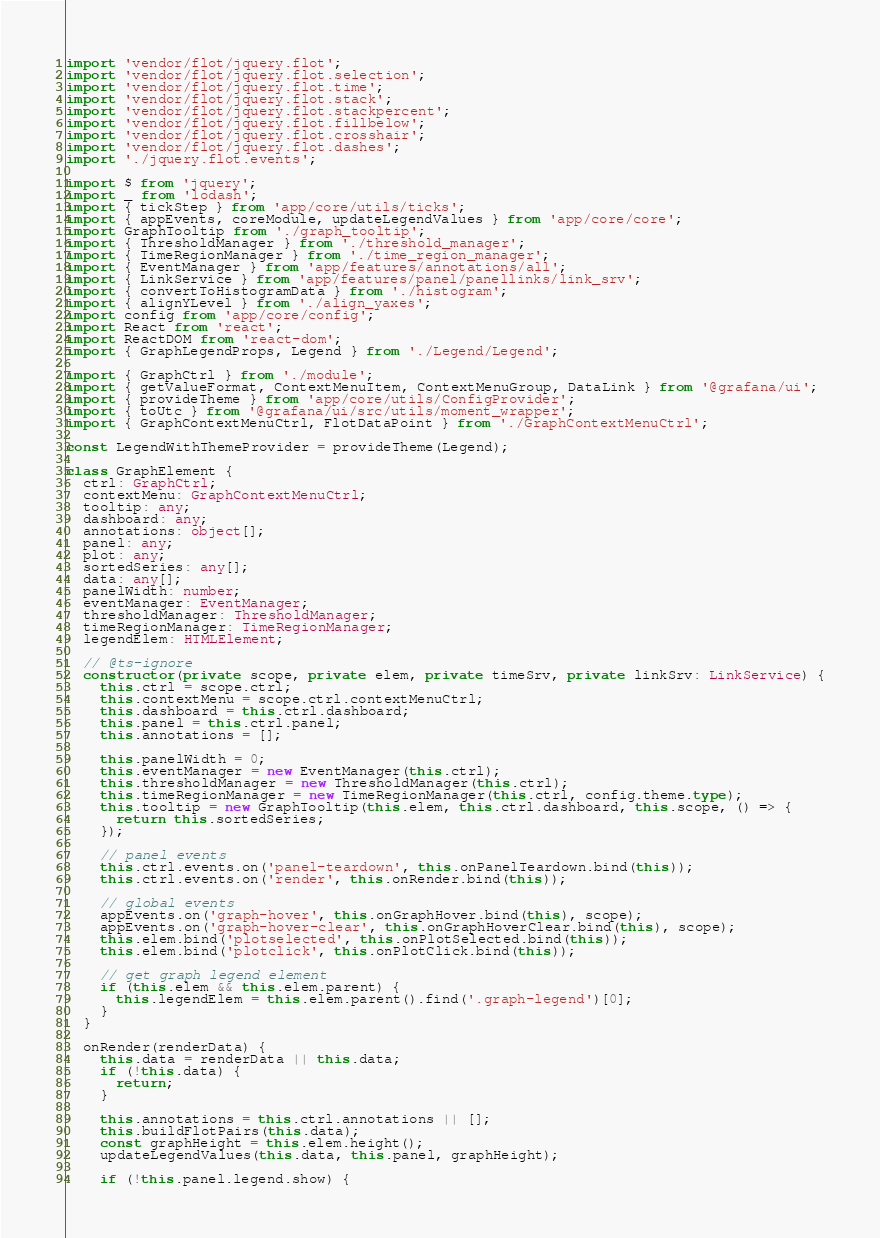Convert code to text. <code><loc_0><loc_0><loc_500><loc_500><_TypeScript_>import 'vendor/flot/jquery.flot';
import 'vendor/flot/jquery.flot.selection';
import 'vendor/flot/jquery.flot.time';
import 'vendor/flot/jquery.flot.stack';
import 'vendor/flot/jquery.flot.stackpercent';
import 'vendor/flot/jquery.flot.fillbelow';
import 'vendor/flot/jquery.flot.crosshair';
import 'vendor/flot/jquery.flot.dashes';
import './jquery.flot.events';

import $ from 'jquery';
import _ from 'lodash';
import { tickStep } from 'app/core/utils/ticks';
import { appEvents, coreModule, updateLegendValues } from 'app/core/core';
import GraphTooltip from './graph_tooltip';
import { ThresholdManager } from './threshold_manager';
import { TimeRegionManager } from './time_region_manager';
import { EventManager } from 'app/features/annotations/all';
import { LinkService } from 'app/features/panel/panellinks/link_srv';
import { convertToHistogramData } from './histogram';
import { alignYLevel } from './align_yaxes';
import config from 'app/core/config';
import React from 'react';
import ReactDOM from 'react-dom';
import { GraphLegendProps, Legend } from './Legend/Legend';

import { GraphCtrl } from './module';
import { getValueFormat, ContextMenuItem, ContextMenuGroup, DataLink } from '@grafana/ui';
import { provideTheme } from 'app/core/utils/ConfigProvider';
import { toUtc } from '@grafana/ui/src/utils/moment_wrapper';
import { GraphContextMenuCtrl, FlotDataPoint } from './GraphContextMenuCtrl';

const LegendWithThemeProvider = provideTheme(Legend);

class GraphElement {
  ctrl: GraphCtrl;
  contextMenu: GraphContextMenuCtrl;
  tooltip: any;
  dashboard: any;
  annotations: object[];
  panel: any;
  plot: any;
  sortedSeries: any[];
  data: any[];
  panelWidth: number;
  eventManager: EventManager;
  thresholdManager: ThresholdManager;
  timeRegionManager: TimeRegionManager;
  legendElem: HTMLElement;

  // @ts-ignore
  constructor(private scope, private elem, private timeSrv, private linkSrv: LinkService) {
    this.ctrl = scope.ctrl;
    this.contextMenu = scope.ctrl.contextMenuCtrl;
    this.dashboard = this.ctrl.dashboard;
    this.panel = this.ctrl.panel;
    this.annotations = [];

    this.panelWidth = 0;
    this.eventManager = new EventManager(this.ctrl);
    this.thresholdManager = new ThresholdManager(this.ctrl);
    this.timeRegionManager = new TimeRegionManager(this.ctrl, config.theme.type);
    this.tooltip = new GraphTooltip(this.elem, this.ctrl.dashboard, this.scope, () => {
      return this.sortedSeries;
    });

    // panel events
    this.ctrl.events.on('panel-teardown', this.onPanelTeardown.bind(this));
    this.ctrl.events.on('render', this.onRender.bind(this));

    // global events
    appEvents.on('graph-hover', this.onGraphHover.bind(this), scope);
    appEvents.on('graph-hover-clear', this.onGraphHoverClear.bind(this), scope);
    this.elem.bind('plotselected', this.onPlotSelected.bind(this));
    this.elem.bind('plotclick', this.onPlotClick.bind(this));

    // get graph legend element
    if (this.elem && this.elem.parent) {
      this.legendElem = this.elem.parent().find('.graph-legend')[0];
    }
  }

  onRender(renderData) {
    this.data = renderData || this.data;
    if (!this.data) {
      return;
    }

    this.annotations = this.ctrl.annotations || [];
    this.buildFlotPairs(this.data);
    const graphHeight = this.elem.height();
    updateLegendValues(this.data, this.panel, graphHeight);

    if (!this.panel.legend.show) {</code> 